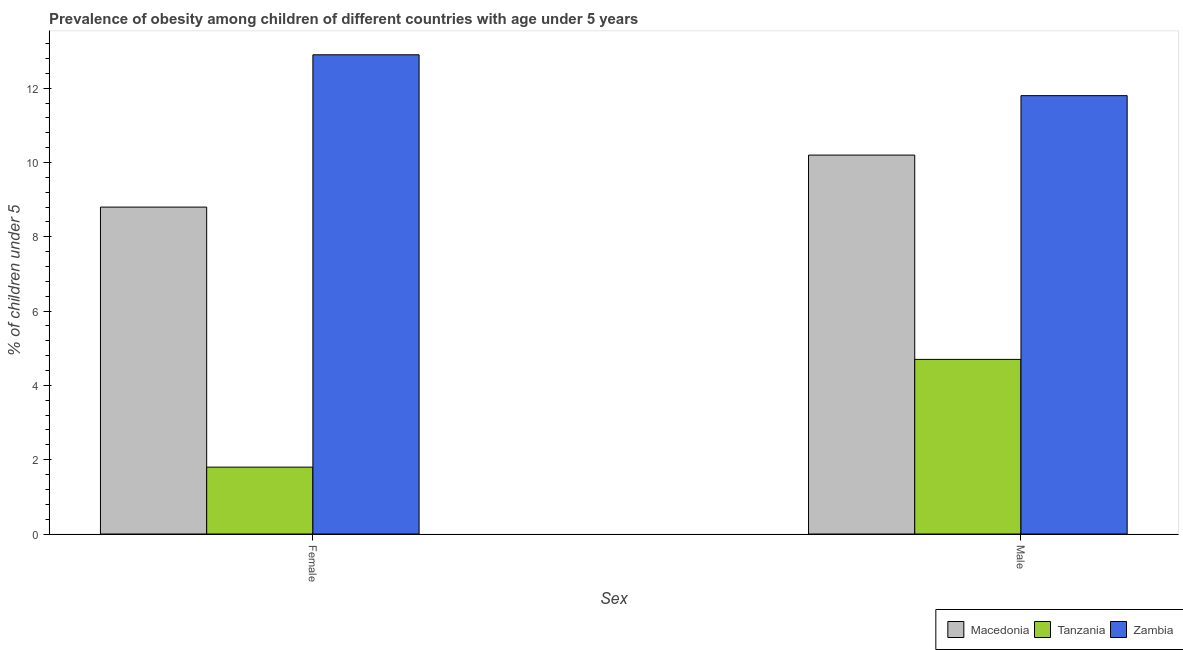How many groups of bars are there?
Your response must be concise. 2. Are the number of bars per tick equal to the number of legend labels?
Provide a succinct answer. Yes. How many bars are there on the 2nd tick from the left?
Provide a succinct answer. 3. What is the label of the 1st group of bars from the left?
Offer a terse response. Female. What is the percentage of obese female children in Zambia?
Your response must be concise. 12.9. Across all countries, what is the maximum percentage of obese male children?
Provide a succinct answer. 11.8. Across all countries, what is the minimum percentage of obese female children?
Provide a short and direct response. 1.8. In which country was the percentage of obese female children maximum?
Your response must be concise. Zambia. In which country was the percentage of obese male children minimum?
Ensure brevity in your answer.  Tanzania. What is the total percentage of obese female children in the graph?
Make the answer very short. 23.5. What is the difference between the percentage of obese male children in Zambia and that in Macedonia?
Offer a very short reply. 1.6. What is the difference between the percentage of obese female children in Tanzania and the percentage of obese male children in Zambia?
Offer a very short reply. -10. What is the average percentage of obese female children per country?
Provide a short and direct response. 7.83. What is the difference between the percentage of obese female children and percentage of obese male children in Zambia?
Give a very brief answer. 1.1. What is the ratio of the percentage of obese female children in Tanzania to that in Zambia?
Provide a short and direct response. 0.14. In how many countries, is the percentage of obese male children greater than the average percentage of obese male children taken over all countries?
Offer a terse response. 2. What does the 2nd bar from the left in Male represents?
Your response must be concise. Tanzania. What does the 3rd bar from the right in Male represents?
Make the answer very short. Macedonia. How many bars are there?
Ensure brevity in your answer.  6. How many countries are there in the graph?
Offer a terse response. 3. Are the values on the major ticks of Y-axis written in scientific E-notation?
Provide a succinct answer. No. Where does the legend appear in the graph?
Ensure brevity in your answer.  Bottom right. How many legend labels are there?
Your answer should be compact. 3. How are the legend labels stacked?
Your answer should be compact. Horizontal. What is the title of the graph?
Provide a short and direct response. Prevalence of obesity among children of different countries with age under 5 years. What is the label or title of the X-axis?
Keep it short and to the point. Sex. What is the label or title of the Y-axis?
Your answer should be very brief.  % of children under 5. What is the  % of children under 5 in Macedonia in Female?
Offer a very short reply. 8.8. What is the  % of children under 5 of Tanzania in Female?
Your response must be concise. 1.8. What is the  % of children under 5 in Zambia in Female?
Give a very brief answer. 12.9. What is the  % of children under 5 of Macedonia in Male?
Give a very brief answer. 10.2. What is the  % of children under 5 of Tanzania in Male?
Keep it short and to the point. 4.7. What is the  % of children under 5 in Zambia in Male?
Your response must be concise. 11.8. Across all Sex, what is the maximum  % of children under 5 of Macedonia?
Provide a succinct answer. 10.2. Across all Sex, what is the maximum  % of children under 5 in Tanzania?
Your answer should be very brief. 4.7. Across all Sex, what is the maximum  % of children under 5 of Zambia?
Ensure brevity in your answer.  12.9. Across all Sex, what is the minimum  % of children under 5 in Macedonia?
Make the answer very short. 8.8. Across all Sex, what is the minimum  % of children under 5 in Tanzania?
Your answer should be very brief. 1.8. Across all Sex, what is the minimum  % of children under 5 in Zambia?
Offer a very short reply. 11.8. What is the total  % of children under 5 in Macedonia in the graph?
Provide a succinct answer. 19. What is the total  % of children under 5 in Tanzania in the graph?
Your response must be concise. 6.5. What is the total  % of children under 5 in Zambia in the graph?
Provide a short and direct response. 24.7. What is the difference between the  % of children under 5 in Macedonia in Female and that in Male?
Your answer should be very brief. -1.4. What is the difference between the  % of children under 5 of Tanzania in Female and that in Male?
Keep it short and to the point. -2.9. What is the difference between the  % of children under 5 in Zambia in Female and that in Male?
Offer a very short reply. 1.1. What is the difference between the  % of children under 5 in Macedonia in Female and the  % of children under 5 in Tanzania in Male?
Your answer should be very brief. 4.1. What is the difference between the  % of children under 5 of Tanzania in Female and the  % of children under 5 of Zambia in Male?
Offer a terse response. -10. What is the average  % of children under 5 of Macedonia per Sex?
Provide a succinct answer. 9.5. What is the average  % of children under 5 of Zambia per Sex?
Offer a terse response. 12.35. What is the difference between the  % of children under 5 of Macedonia and  % of children under 5 of Zambia in Male?
Offer a very short reply. -1.6. What is the ratio of the  % of children under 5 of Macedonia in Female to that in Male?
Provide a succinct answer. 0.86. What is the ratio of the  % of children under 5 in Tanzania in Female to that in Male?
Provide a succinct answer. 0.38. What is the ratio of the  % of children under 5 in Zambia in Female to that in Male?
Keep it short and to the point. 1.09. What is the difference between the highest and the second highest  % of children under 5 in Macedonia?
Offer a terse response. 1.4. What is the difference between the highest and the second highest  % of children under 5 of Tanzania?
Offer a very short reply. 2.9. What is the difference between the highest and the second highest  % of children under 5 in Zambia?
Provide a succinct answer. 1.1. What is the difference between the highest and the lowest  % of children under 5 in Macedonia?
Provide a succinct answer. 1.4. What is the difference between the highest and the lowest  % of children under 5 of Tanzania?
Offer a terse response. 2.9. 